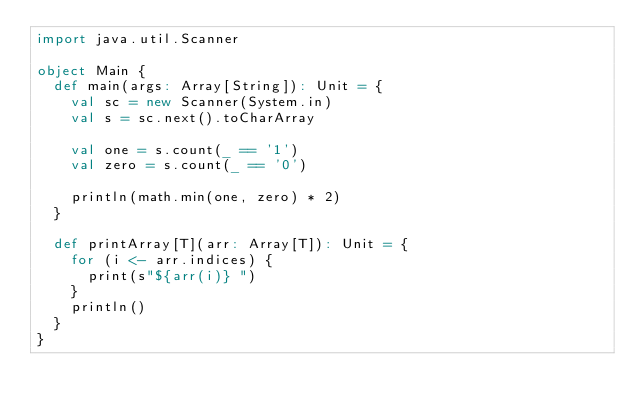Convert code to text. <code><loc_0><loc_0><loc_500><loc_500><_Scala_>import java.util.Scanner

object Main {
  def main(args: Array[String]): Unit = {
    val sc = new Scanner(System.in)
    val s = sc.next().toCharArray
    
    val one = s.count(_ == '1')
    val zero = s.count(_ == '0')
    
    println(math.min(one, zero) * 2)
  }
  
  def printArray[T](arr: Array[T]): Unit = {
    for (i <- arr.indices) {
      print(s"${arr(i)} ")
    }
    println()
  }
}</code> 